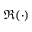Convert formula to latex. <formula><loc_0><loc_0><loc_500><loc_500>\Re ( \cdot )</formula> 